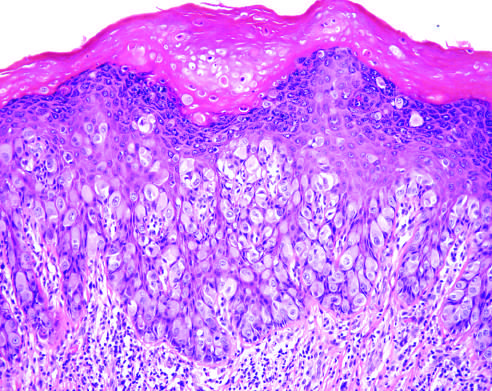re the necrotic cells present in the underlying dermis?
Answer the question using a single word or phrase. No 